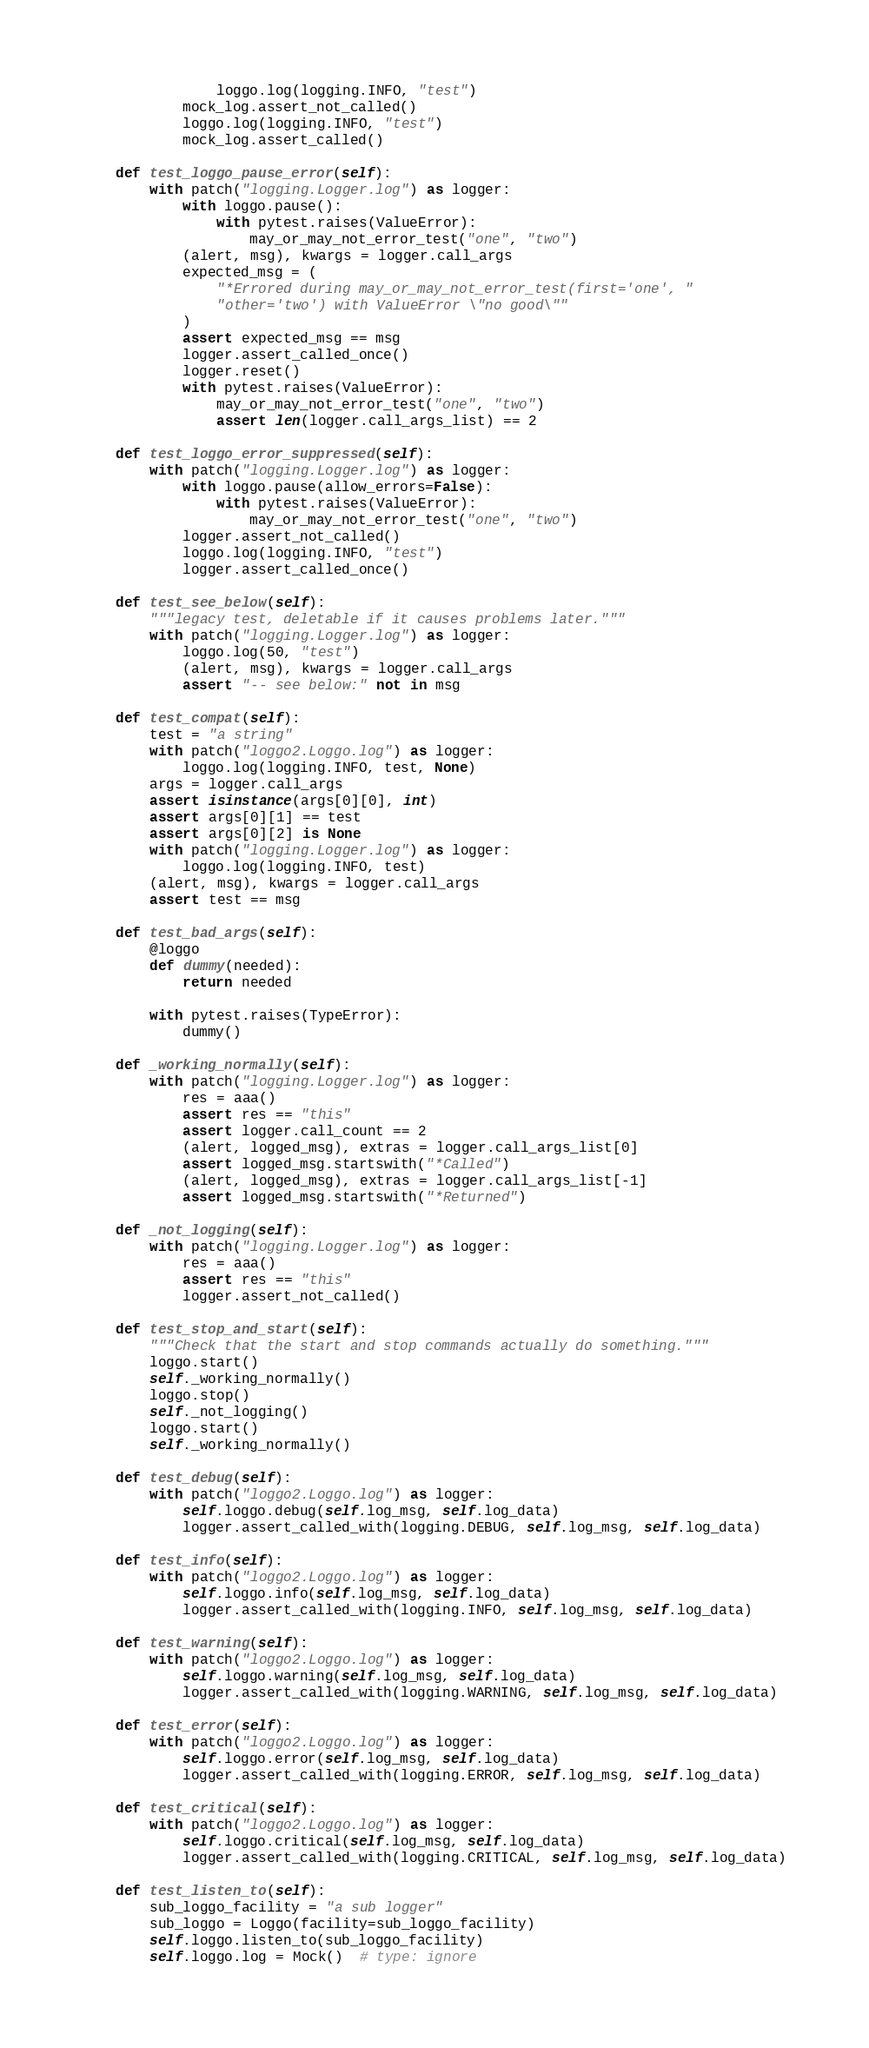Convert code to text. <code><loc_0><loc_0><loc_500><loc_500><_Python_>                loggo.log(logging.INFO, "test")
            mock_log.assert_not_called()
            loggo.log(logging.INFO, "test")
            mock_log.assert_called()

    def test_loggo_pause_error(self):
        with patch("logging.Logger.log") as logger:
            with loggo.pause():
                with pytest.raises(ValueError):
                    may_or_may_not_error_test("one", "two")
            (alert, msg), kwargs = logger.call_args
            expected_msg = (
                "*Errored during may_or_may_not_error_test(first='one', "
                "other='two') with ValueError \"no good\""
            )
            assert expected_msg == msg
            logger.assert_called_once()
            logger.reset()
            with pytest.raises(ValueError):
                may_or_may_not_error_test("one", "two")
                assert len(logger.call_args_list) == 2

    def test_loggo_error_suppressed(self):
        with patch("logging.Logger.log") as logger:
            with loggo.pause(allow_errors=False):
                with pytest.raises(ValueError):
                    may_or_may_not_error_test("one", "two")
            logger.assert_not_called()
            loggo.log(logging.INFO, "test")
            logger.assert_called_once()

    def test_see_below(self):
        """legacy test, deletable if it causes problems later."""
        with patch("logging.Logger.log") as logger:
            loggo.log(50, "test")
            (alert, msg), kwargs = logger.call_args
            assert "-- see below:" not in msg

    def test_compat(self):
        test = "a string"
        with patch("loggo2.Loggo.log") as logger:
            loggo.log(logging.INFO, test, None)
        args = logger.call_args
        assert isinstance(args[0][0], int)
        assert args[0][1] == test
        assert args[0][2] is None
        with patch("logging.Logger.log") as logger:
            loggo.log(logging.INFO, test)
        (alert, msg), kwargs = logger.call_args
        assert test == msg

    def test_bad_args(self):
        @loggo
        def dummy(needed):
            return needed

        with pytest.raises(TypeError):
            dummy()

    def _working_normally(self):
        with patch("logging.Logger.log") as logger:
            res = aaa()
            assert res == "this"
            assert logger.call_count == 2
            (alert, logged_msg), extras = logger.call_args_list[0]
            assert logged_msg.startswith("*Called")
            (alert, logged_msg), extras = logger.call_args_list[-1]
            assert logged_msg.startswith("*Returned")

    def _not_logging(self):
        with patch("logging.Logger.log") as logger:
            res = aaa()
            assert res == "this"
            logger.assert_not_called()

    def test_stop_and_start(self):
        """Check that the start and stop commands actually do something."""
        loggo.start()
        self._working_normally()
        loggo.stop()
        self._not_logging()
        loggo.start()
        self._working_normally()

    def test_debug(self):
        with patch("loggo2.Loggo.log") as logger:
            self.loggo.debug(self.log_msg, self.log_data)
            logger.assert_called_with(logging.DEBUG, self.log_msg, self.log_data)

    def test_info(self):
        with patch("loggo2.Loggo.log") as logger:
            self.loggo.info(self.log_msg, self.log_data)
            logger.assert_called_with(logging.INFO, self.log_msg, self.log_data)

    def test_warning(self):
        with patch("loggo2.Loggo.log") as logger:
            self.loggo.warning(self.log_msg, self.log_data)
            logger.assert_called_with(logging.WARNING, self.log_msg, self.log_data)

    def test_error(self):
        with patch("loggo2.Loggo.log") as logger:
            self.loggo.error(self.log_msg, self.log_data)
            logger.assert_called_with(logging.ERROR, self.log_msg, self.log_data)

    def test_critical(self):
        with patch("loggo2.Loggo.log") as logger:
            self.loggo.critical(self.log_msg, self.log_data)
            logger.assert_called_with(logging.CRITICAL, self.log_msg, self.log_data)

    def test_listen_to(self):
        sub_loggo_facility = "a sub logger"
        sub_loggo = Loggo(facility=sub_loggo_facility)
        self.loggo.listen_to(sub_loggo_facility)
        self.loggo.log = Mock()  # type: ignore</code> 